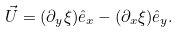Convert formula to latex. <formula><loc_0><loc_0><loc_500><loc_500>\vec { U } = ( \partial _ { y } \xi ) \hat { e } _ { x } - ( \partial _ { x } \xi ) \hat { e } _ { y } .</formula> 